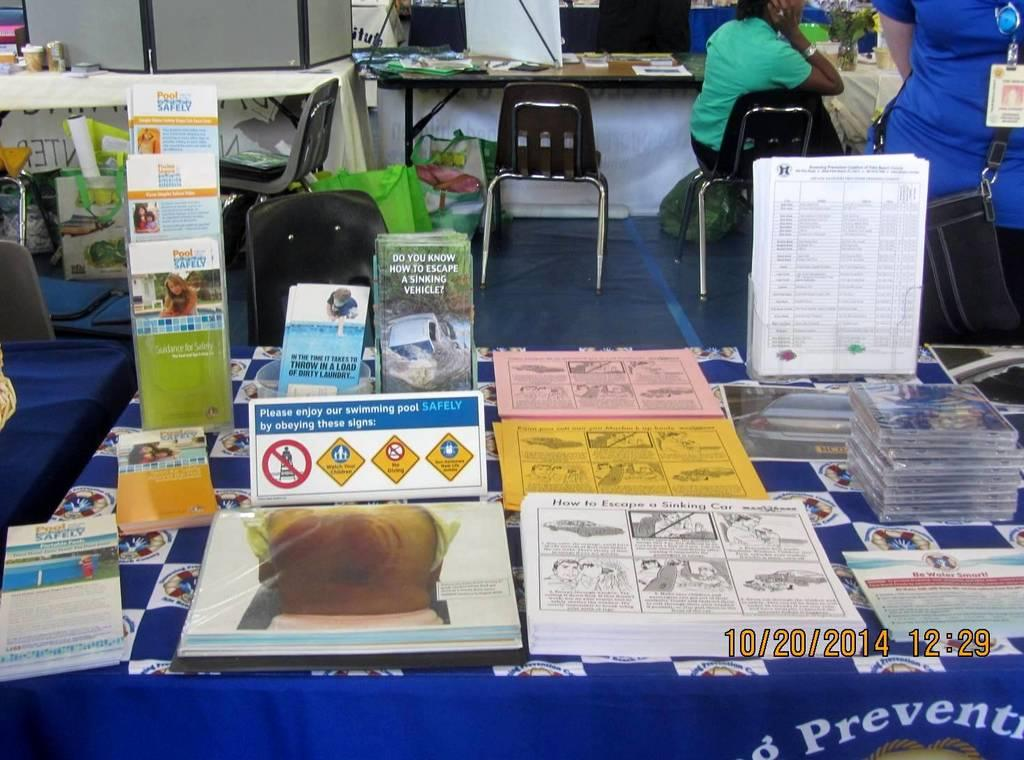What is on the table in the image? There is a set of books and pamphlets on the table. What type of furniture is present in the image? Chairs are present in the image. What are the people in the image doing? People are sitting on the chairs and standing near the table. Can you tell me where the gun is located in the image? There is no gun present in the image. What type of stove is visible in the image? There is no stove present in the image. 